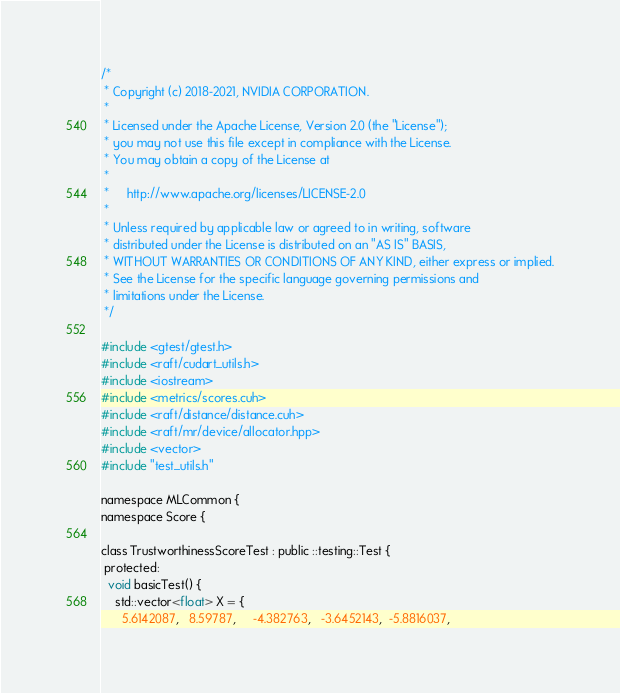Convert code to text. <code><loc_0><loc_0><loc_500><loc_500><_Cuda_>/*
 * Copyright (c) 2018-2021, NVIDIA CORPORATION.
 *
 * Licensed under the Apache License, Version 2.0 (the "License");
 * you may not use this file except in compliance with the License.
 * You may obtain a copy of the License at
 *
 *     http://www.apache.org/licenses/LICENSE-2.0
 *
 * Unless required by applicable law or agreed to in writing, software
 * distributed under the License is distributed on an "AS IS" BASIS,
 * WITHOUT WARRANTIES OR CONDITIONS OF ANY KIND, either express or implied.
 * See the License for the specific language governing permissions and
 * limitations under the License.
 */

#include <gtest/gtest.h>
#include <raft/cudart_utils.h>
#include <iostream>
#include <metrics/scores.cuh>
#include <raft/distance/distance.cuh>
#include <raft/mr/device/allocator.hpp>
#include <vector>
#include "test_utils.h"

namespace MLCommon {
namespace Score {

class TrustworthinessScoreTest : public ::testing::Test {
 protected:
  void basicTest() {
    std::vector<float> X = {
      5.6142087,   8.59787,     -4.382763,   -3.6452143,  -5.8816037,</code> 